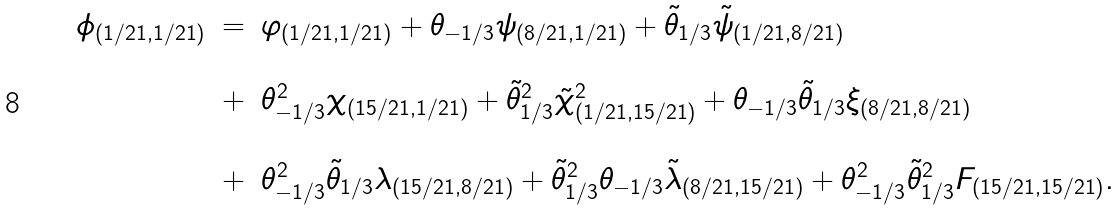<formula> <loc_0><loc_0><loc_500><loc_500>\begin{array} { l c l } \phi _ { ( { 1 / 2 1 , 1 / 2 1 } ) } & = & \varphi _ { ( { 1 / 2 1 , 1 / 2 1 } ) } + \theta _ { - 1 / 3 } \psi _ { ( { 8 / 2 1 , 1 / 2 1 } ) } + \tilde { \theta } _ { 1 / 3 } \tilde { \psi } _ { ( { 1 / 2 1 , 8 / 2 1 } ) } \\ \\ & + & \theta ^ { 2 } _ { - 1 / 3 } \chi _ { ( { 1 5 / 2 1 , 1 / 2 1 } ) } + \tilde { \theta } ^ { 2 } _ { 1 / 3 } \tilde { \chi } ^ { 2 } _ { ( { 1 / 2 1 , 1 5 / 2 1 } ) } + \theta _ { - 1 / 3 } \tilde { \theta } _ { 1 / 3 } \xi _ { ( { 8 / 2 1 , 8 / 2 1 } ) } \\ \\ & + & \theta ^ { 2 } _ { - 1 / 3 } \tilde { \theta } _ { 1 / 3 } \lambda _ { ( { 1 5 / 2 1 , 8 / 2 1 } ) } + \tilde { \theta } ^ { 2 } _ { 1 / 3 } \theta _ { - 1 / 3 } \tilde { \lambda } _ { ( { 8 / 2 1 , 1 5 / 2 1 } ) } + \theta ^ { 2 } _ { - 1 / 3 } \tilde { \theta } ^ { 2 } _ { 1 / 3 } F _ { ( { 1 5 / 2 1 , 1 5 / 2 1 } ) } . \end{array}</formula> 